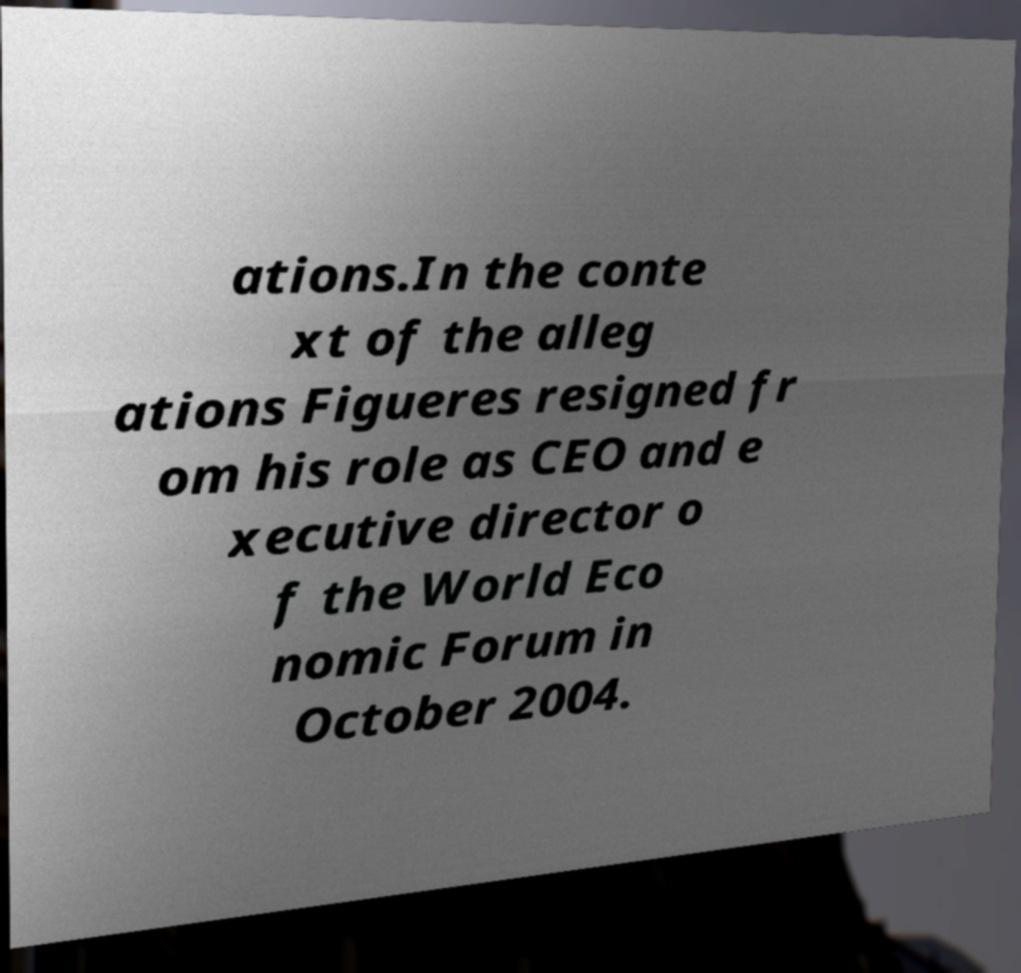Can you read and provide the text displayed in the image?This photo seems to have some interesting text. Can you extract and type it out for me? ations.In the conte xt of the alleg ations Figueres resigned fr om his role as CEO and e xecutive director o f the World Eco nomic Forum in October 2004. 